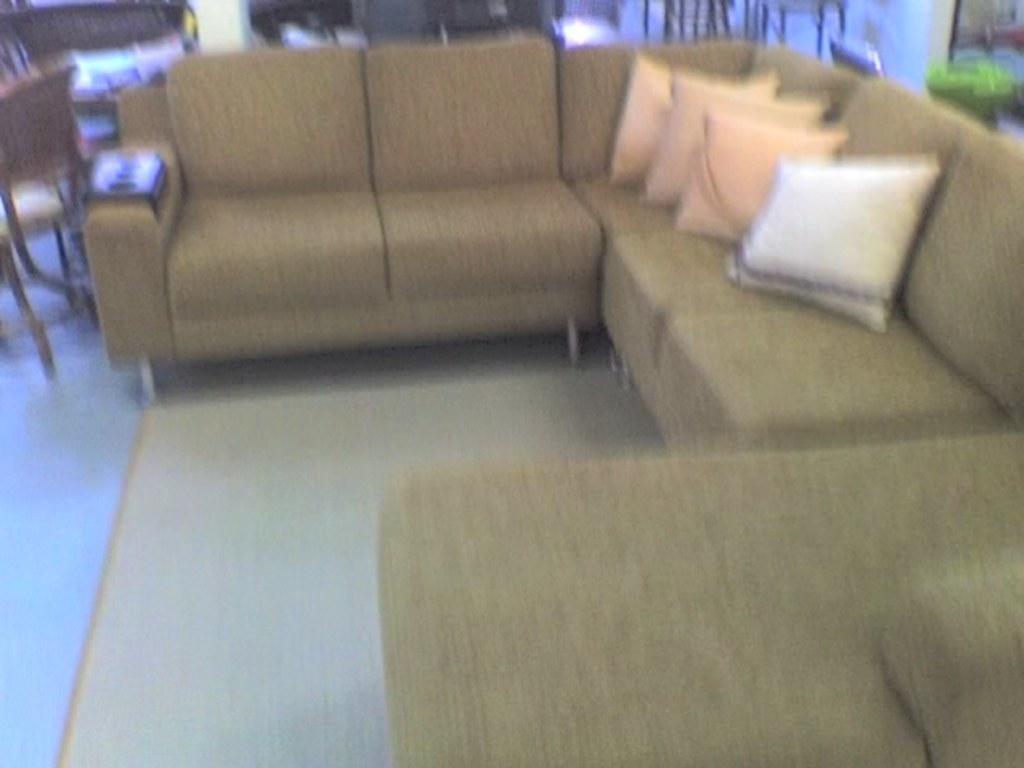Describe this image in one or two sentences. This picture shows a sofa set in the room on which some pillows were placed here. There is a chair beside the sofa. 